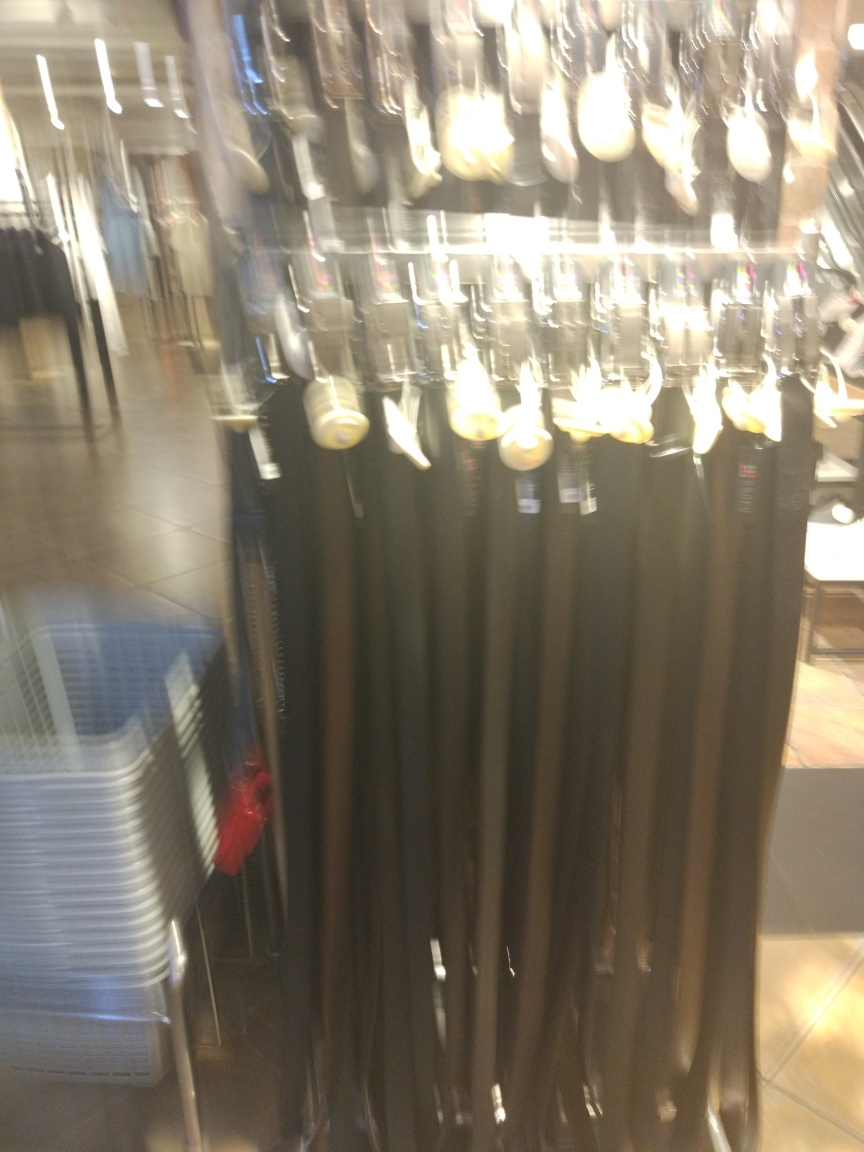Can you describe what is shown in this blurry image? Despite the blur, it seems to be an image of a clothing rack, possibly at a retail store, showing pants or jeans hung on display hangers. How might the blur affect a customer's ability to shop? The blur reduces the ability to see details such as the texture, color, and fine characteristics of the fabric, which are important for customers when choosing clothing. Clear visuals are crucial for making informed purchasing decisions. 